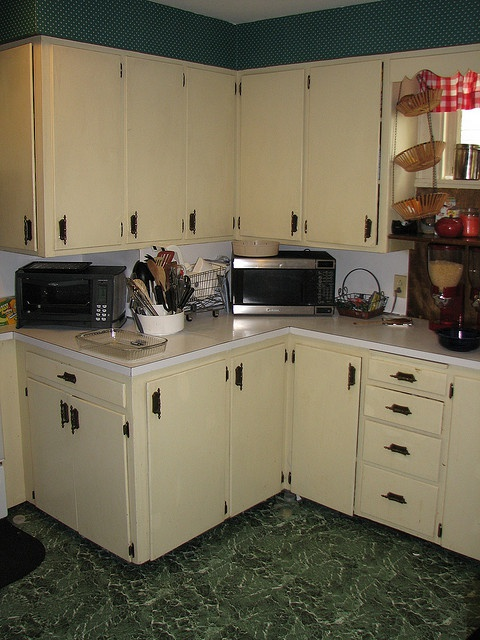Describe the objects in this image and their specific colors. I can see microwave in black and gray tones, oven in black and gray tones, microwave in black, gray, white, and darkgray tones, bowl in black, maroon, brown, and gray tones, and bowl in black, maroon, and brown tones in this image. 